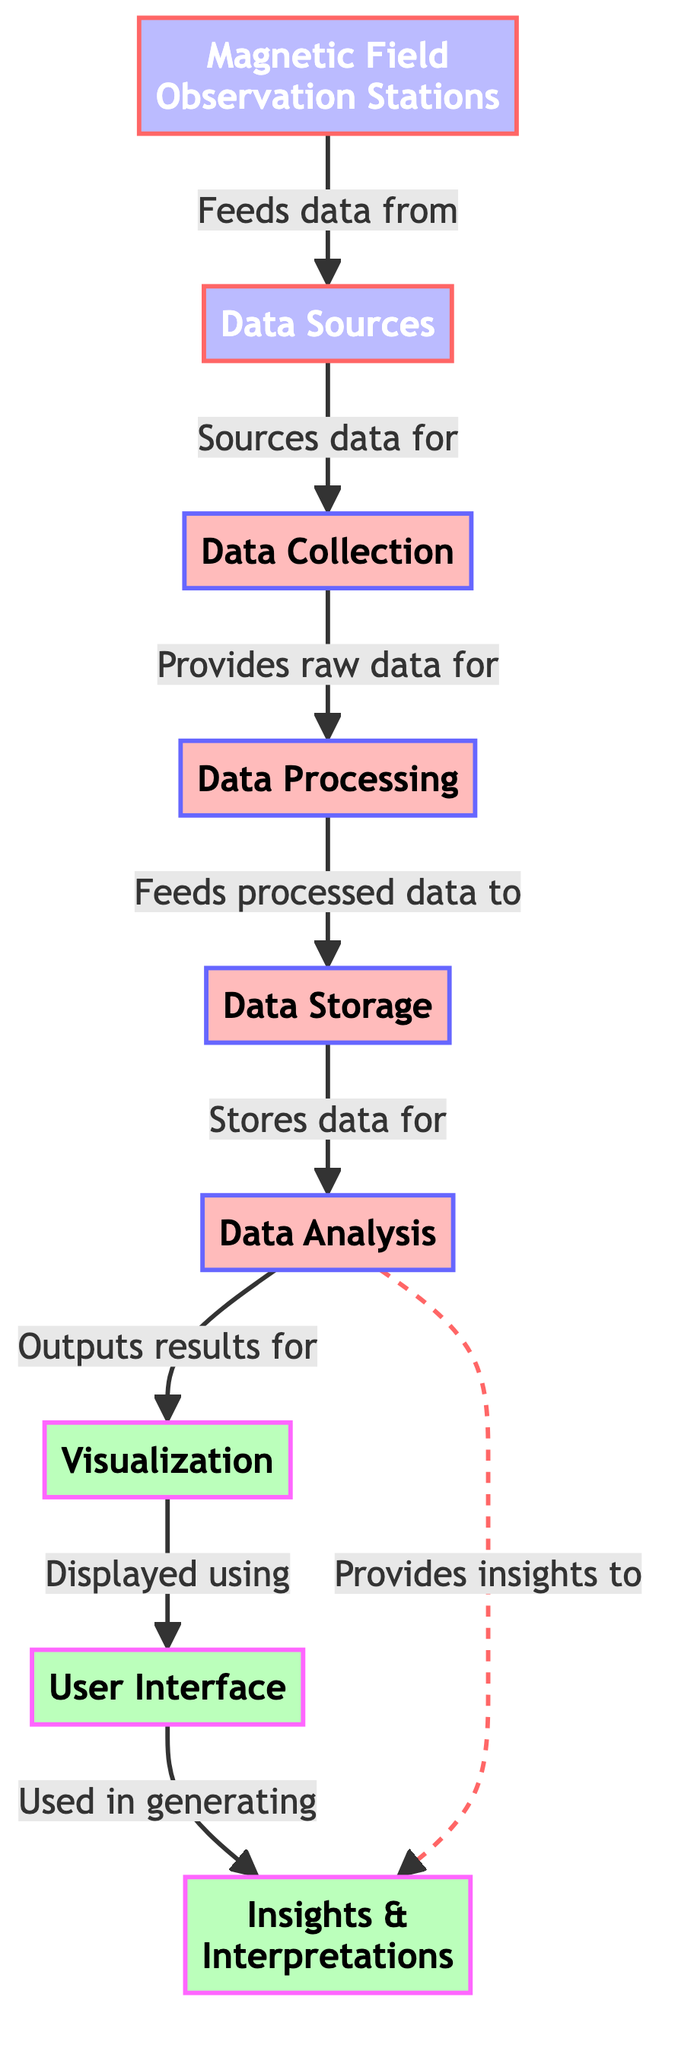What is the first node in the diagram? The first node is labeled "Magnetic Field Observation Stations," which indicates the starting point of the data flow in the process depicted in the diagram.
Answer: Magnetic Field Observation Stations How many process nodes are in the diagram? The diagram contains four process nodes, which are "Data Collection," "Data Processing," "Data Storage," and "Data Analysis." These indicate the stages of processing the data.
Answer: Four What does the "Data Collection" node provide for processing? The "Data Collection" node provides raw data for the "Data Processing" node, indicating that this is the step where data is gathered for further analysis.
Answer: Raw data Which node outputs results for visualization? The "Data Analysis" node outputs results for "Visualization," showing that the analysis phase leads directly to the visual representation of the data.
Answer: Visualization What is the purpose of the "User Interface" node? The "User Interface" node is displayed using the "Visualization" node, indicating that the visualization is meant to be interacted with or viewed through a user interface.
Answer: Displayed How does the flow of data go from storage to analysis? The flow from "Data Storage" to "Data Analysis" occurs as "Data Storage" stores the data that will be analyzed, demonstrating a sequential connection in the processing workflow.
Answer: Stores data for What type of relationship exists between "Data Analysis" and "Insights & Interpretations"? There is a direct relationship where "Data Analysis" provides insights to "Insights & Interpretations," indicating that analysis leads to understanding and conclusions drawn from the data.
Answer: Provides insights to What role does "Data Sources" play in the diagram? The "Data Sources" node acts as the origin for the data needed in the "Data Collection" process, highlighting its importance in initiating the data-gathering process.
Answer: Sources data for What is the output of the entire process depicted in the diagram? The final output of the entire process, as represented in the diagram, is "Insights & Interpretations," showing that the goal of the process is to draw understanding from the analyzed data.
Answer: Insights & Interpretations 